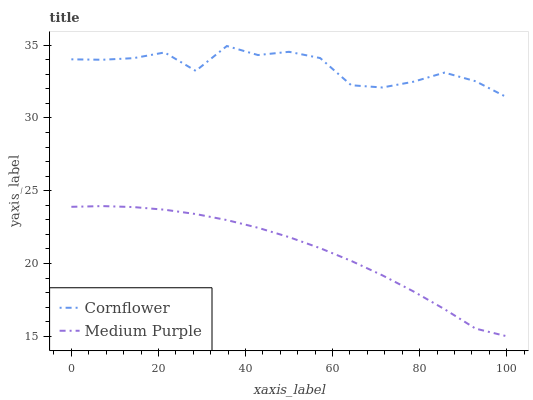Does Cornflower have the minimum area under the curve?
Answer yes or no. No. Is Cornflower the smoothest?
Answer yes or no. No. Does Cornflower have the lowest value?
Answer yes or no. No. Is Medium Purple less than Cornflower?
Answer yes or no. Yes. Is Cornflower greater than Medium Purple?
Answer yes or no. Yes. Does Medium Purple intersect Cornflower?
Answer yes or no. No. 